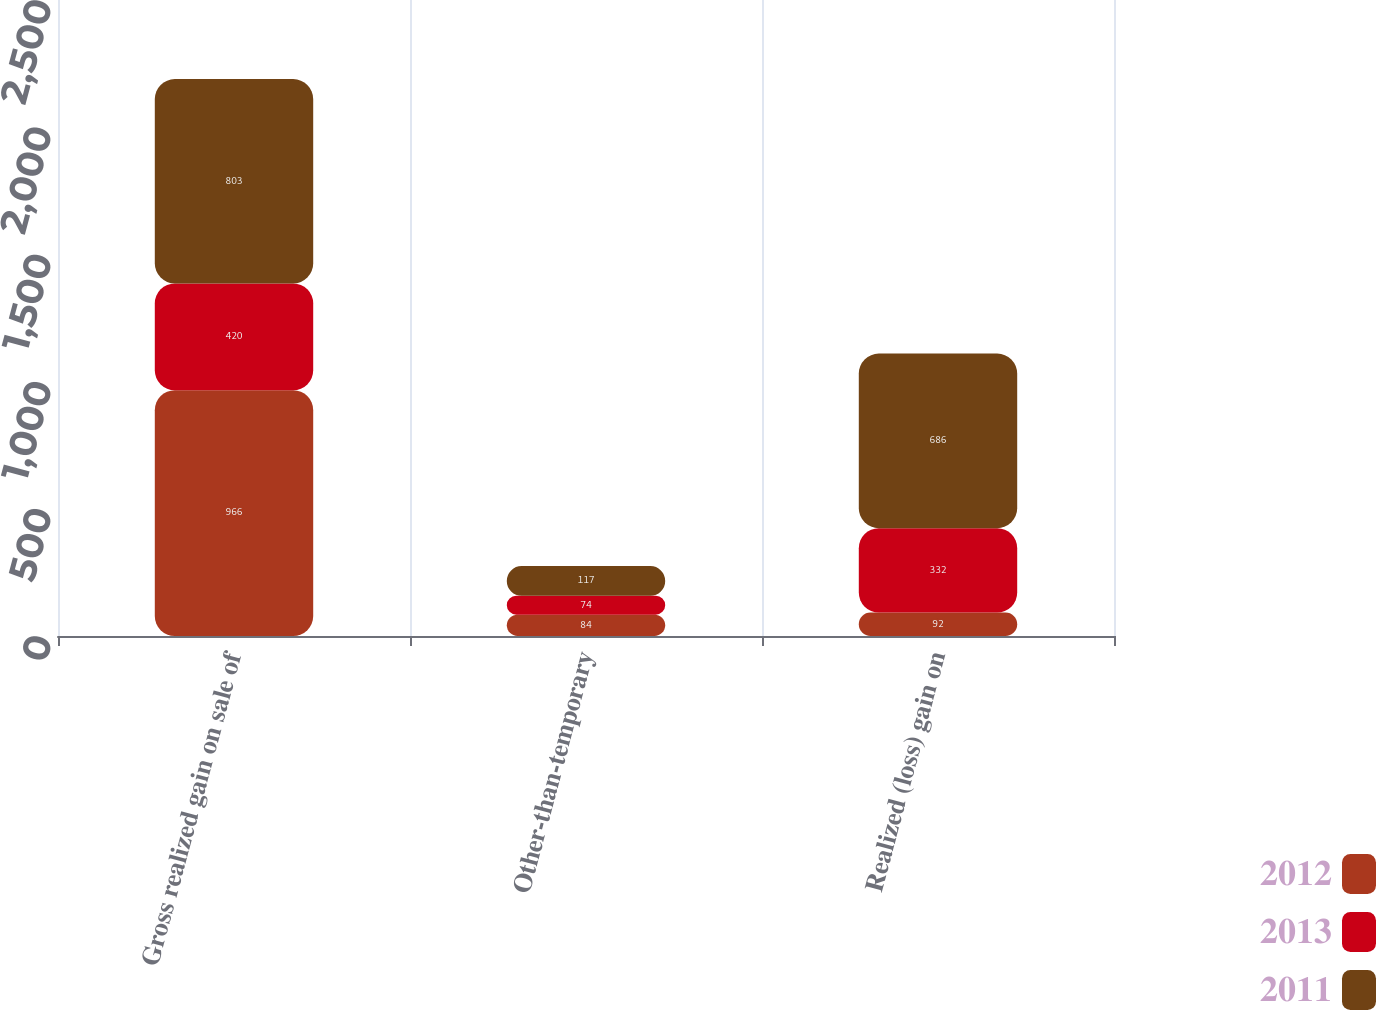Convert chart to OTSL. <chart><loc_0><loc_0><loc_500><loc_500><stacked_bar_chart><ecel><fcel>Gross realized gain on sale of<fcel>Other-than-temporary<fcel>Realized (loss) gain on<nl><fcel>2012<fcel>966<fcel>84<fcel>92<nl><fcel>2013<fcel>420<fcel>74<fcel>332<nl><fcel>2011<fcel>803<fcel>117<fcel>686<nl></chart> 